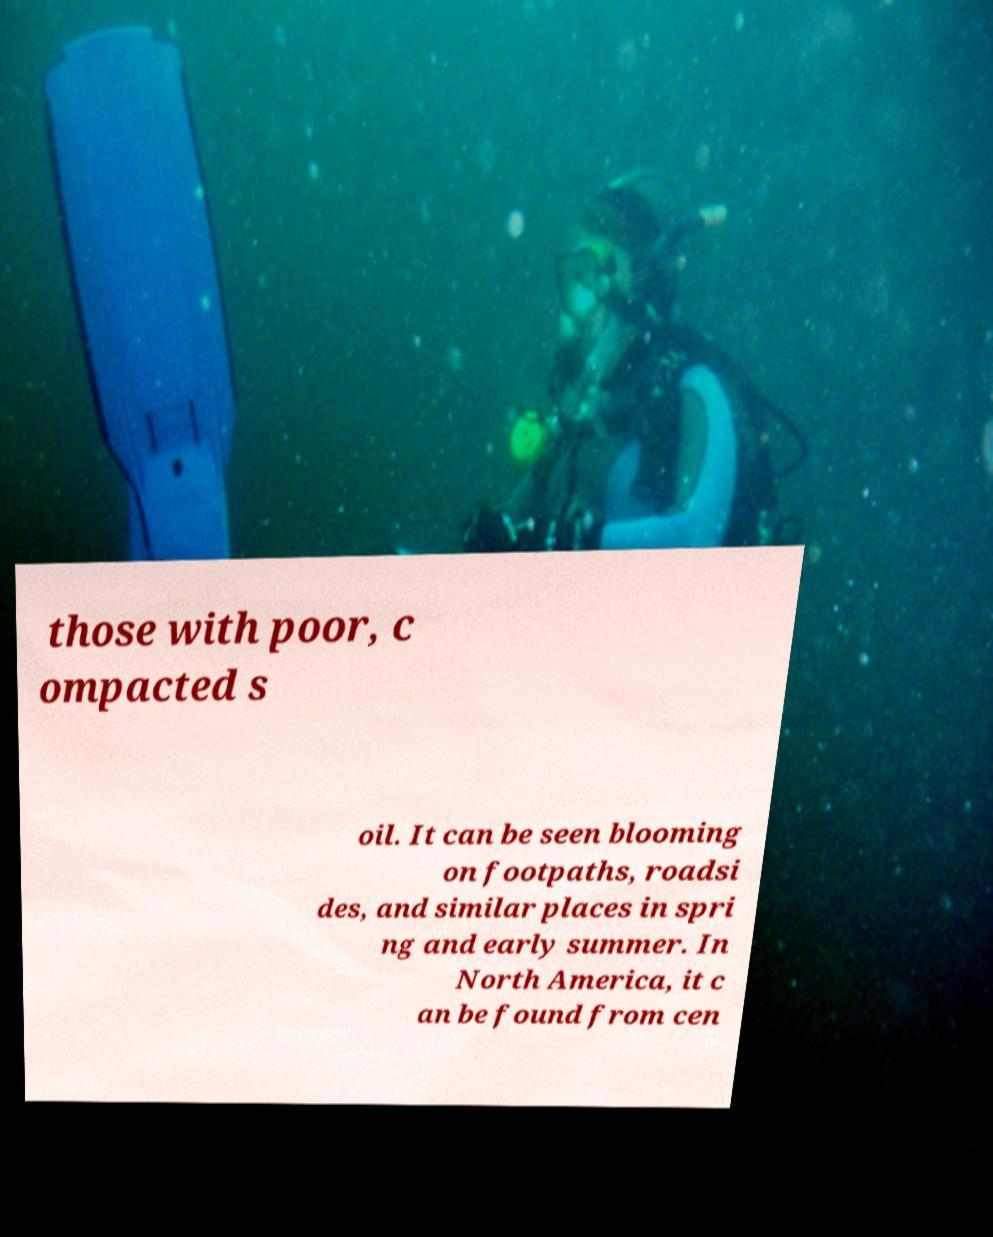Could you extract and type out the text from this image? those with poor, c ompacted s oil. It can be seen blooming on footpaths, roadsi des, and similar places in spri ng and early summer. In North America, it c an be found from cen 